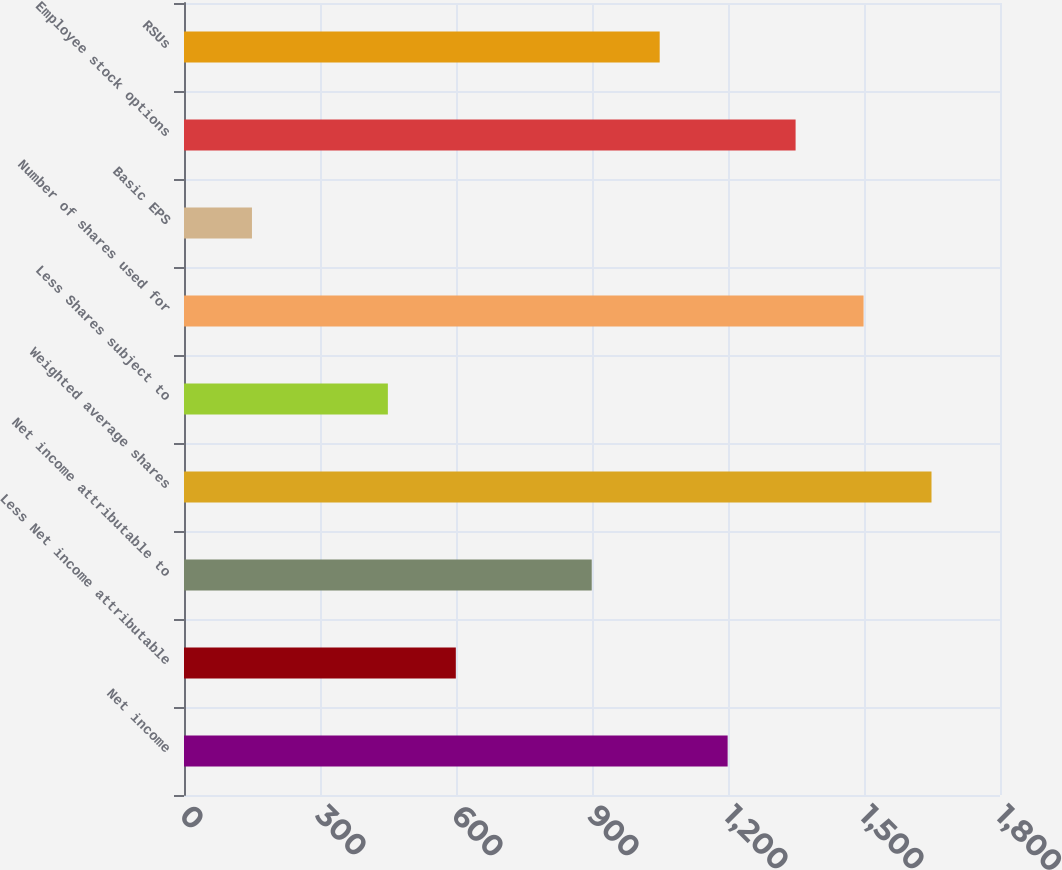Convert chart to OTSL. <chart><loc_0><loc_0><loc_500><loc_500><bar_chart><fcel>Net income<fcel>Less Net income attributable<fcel>Net income attributable to<fcel>Weighted average shares<fcel>Less Shares subject to<fcel>Number of shares used for<fcel>Basic EPS<fcel>Employee stock options<fcel>RSUs<nl><fcel>1199.21<fcel>599.61<fcel>899.41<fcel>1648.91<fcel>449.71<fcel>1499.01<fcel>149.91<fcel>1349.11<fcel>1049.31<nl></chart> 